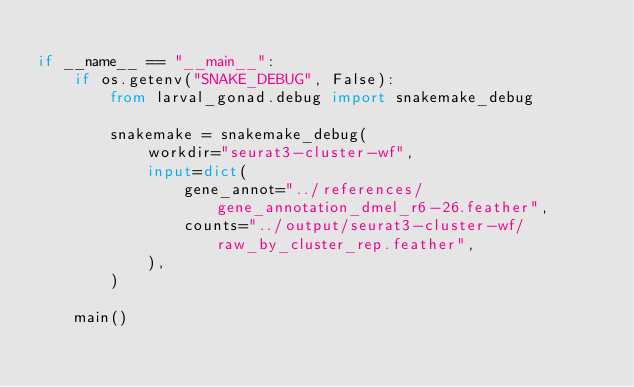<code> <loc_0><loc_0><loc_500><loc_500><_Python_>
if __name__ == "__main__":
    if os.getenv("SNAKE_DEBUG", False):
        from larval_gonad.debug import snakemake_debug

        snakemake = snakemake_debug(
            workdir="seurat3-cluster-wf",
            input=dict(
                gene_annot="../references/gene_annotation_dmel_r6-26.feather",
                counts="../output/seurat3-cluster-wf/raw_by_cluster_rep.feather",
            ),
        )

    main()
</code> 